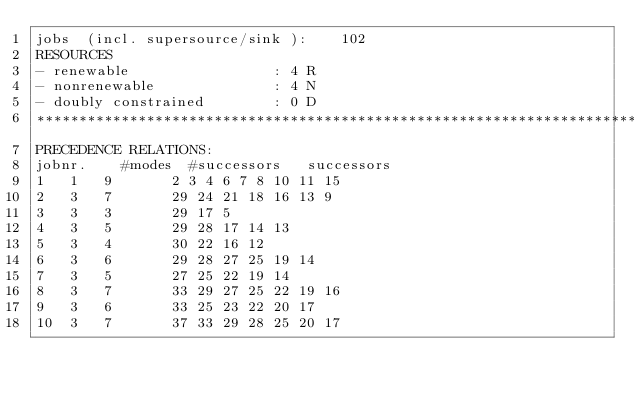<code> <loc_0><loc_0><loc_500><loc_500><_ObjectiveC_>jobs  (incl. supersource/sink ):	102
RESOURCES
- renewable                 : 4 R
- nonrenewable              : 4 N
- doubly constrained        : 0 D
************************************************************************
PRECEDENCE RELATIONS:
jobnr.    #modes  #successors   successors
1	1	9		2 3 4 6 7 8 10 11 15 
2	3	7		29 24 21 18 16 13 9 
3	3	3		29 17 5 
4	3	5		29 28 17 14 13 
5	3	4		30 22 16 12 
6	3	6		29 28 27 25 19 14 
7	3	5		27 25 22 19 14 
8	3	7		33 29 27 25 22 19 16 
9	3	6		33 25 23 22 20 17 
10	3	7		37 33 29 28 25 20 17 </code> 